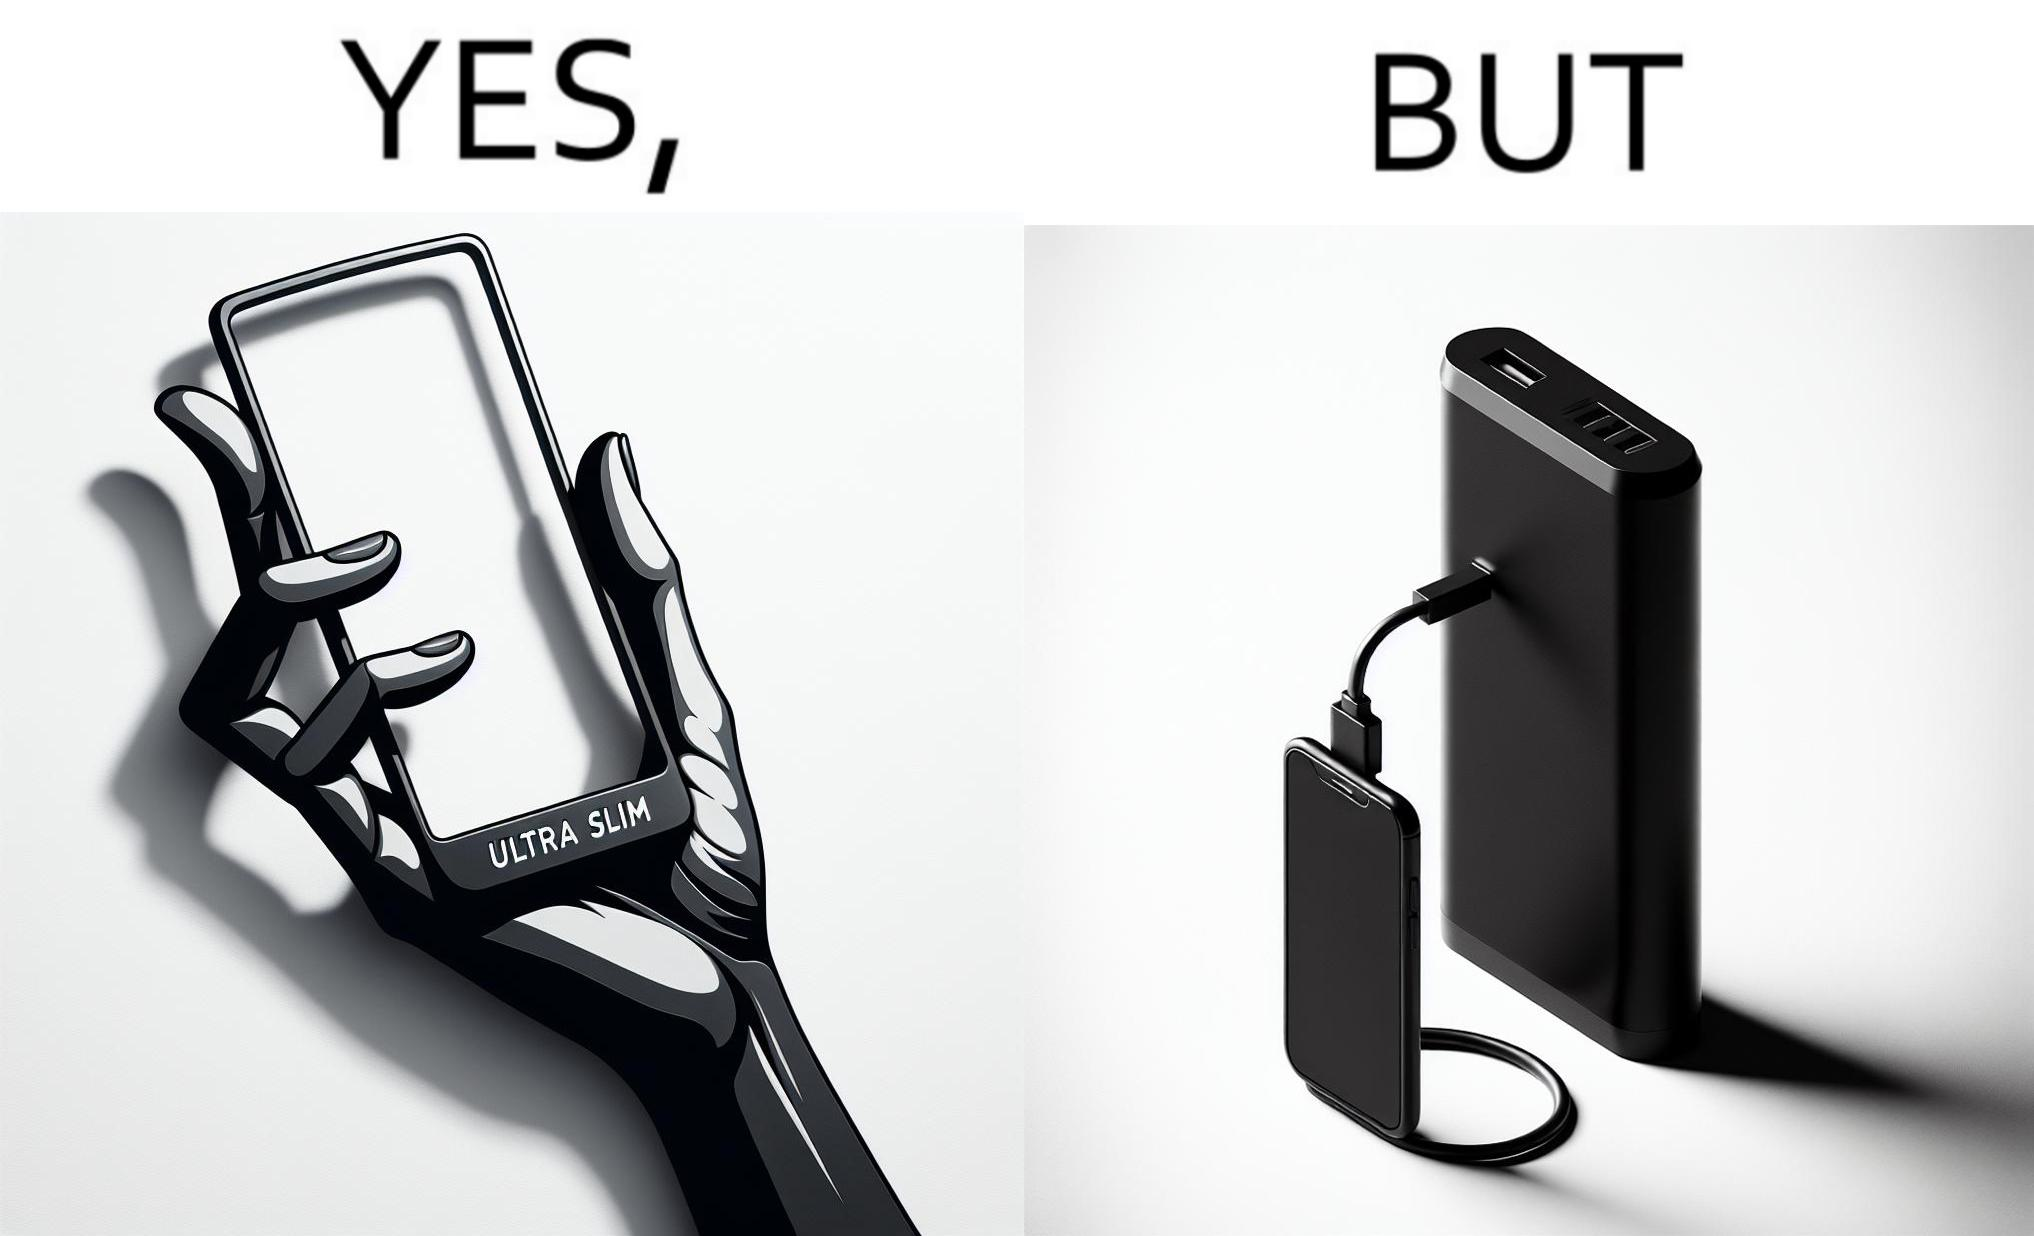Provide a description of this image. The image is satirical because even though the mobile phone has been developed to be very slim, it requires frequent recharging which makes the mobile phone useless without a big, heavy and thick power bank. 